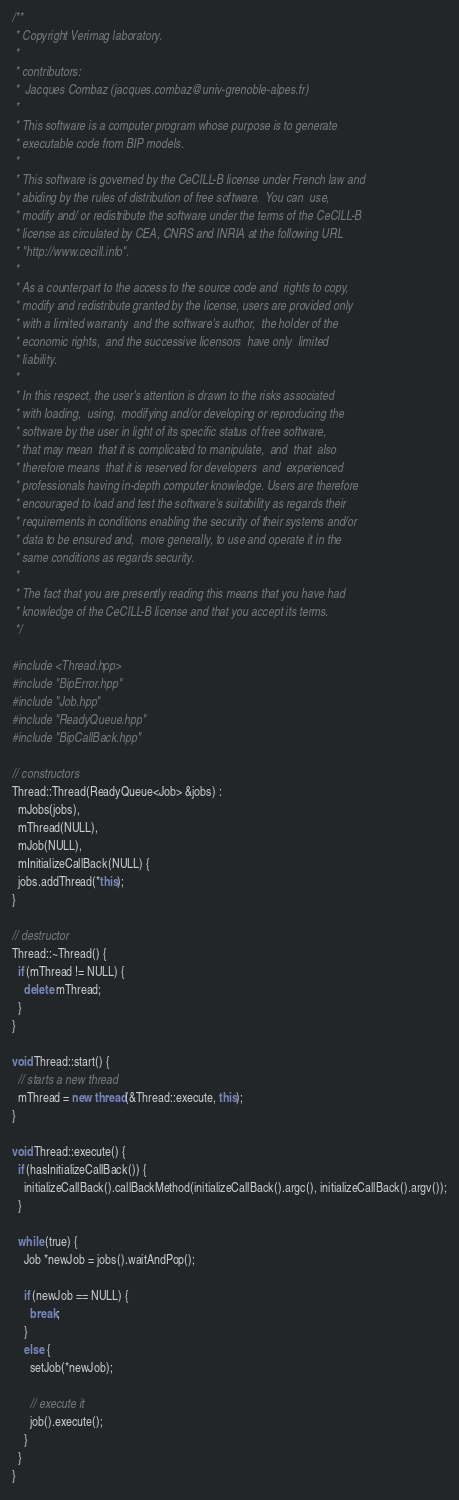Convert code to text. <code><loc_0><loc_0><loc_500><loc_500><_C++_>/**
 * Copyright Verimag laboratory.
 * 
 * contributors:
 *  Jacques Combaz (jacques.combaz@univ-grenoble-alpes.fr)
 * 
 * This software is a computer program whose purpose is to generate
 * executable code from BIP models.
 * 
 * This software is governed by the CeCILL-B license under French law and
 * abiding by the rules of distribution of free software.  You can  use, 
 * modify and/ or redistribute the software under the terms of the CeCILL-B
 * license as circulated by CEA, CNRS and INRIA at the following URL
 * "http://www.cecill.info".
 * 
 * As a counterpart to the access to the source code and  rights to copy,
 * modify and redistribute granted by the license, users are provided only
 * with a limited warranty  and the software's author,  the holder of the
 * economic rights,  and the successive licensors  have only  limited
 * liability.
 *
 * In this respect, the user's attention is drawn to the risks associated
 * with loading,  using,  modifying and/or developing or reproducing the
 * software by the user in light of its specific status of free software,
 * that may mean  that it is complicated to manipulate,  and  that  also
 * therefore means  that it is reserved for developers  and  experienced
 * professionals having in-depth computer knowledge. Users are therefore
 * encouraged to load and test the software's suitability as regards their
 * requirements in conditions enabling the security of their systems and/or 
 * data to be ensured and,  more generally, to use and operate it in the 
 * same conditions as regards security.
 * 
 * The fact that you are presently reading this means that you have had
 * knowledge of the CeCILL-B license and that you accept its terms.
 */

#include <Thread.hpp>
#include "BipError.hpp"
#include "Job.hpp"
#include "ReadyQueue.hpp"
#include "BipCallBack.hpp"

// constructors
Thread::Thread(ReadyQueue<Job> &jobs) :
  mJobs(jobs),
  mThread(NULL),
  mJob(NULL),
  mInitializeCallBack(NULL) {
  jobs.addThread(*this);
}

// destructor
Thread::~Thread() {
  if (mThread != NULL) {
    delete mThread;
  }
}

void Thread::start() {
  // starts a new thread
  mThread = new thread(&Thread::execute, this);
}

void Thread::execute() {
  if (hasInitializeCallBack()) {
    initializeCallBack().callBackMethod(initializeCallBack().argc(), initializeCallBack().argv());
  }
  
  while (true) {
    Job *newJob = jobs().waitAndPop();

    if (newJob == NULL) {
      break;
    }
    else {
      setJob(*newJob);

      // execute it
      job().execute();
    }
  }
}
</code> 